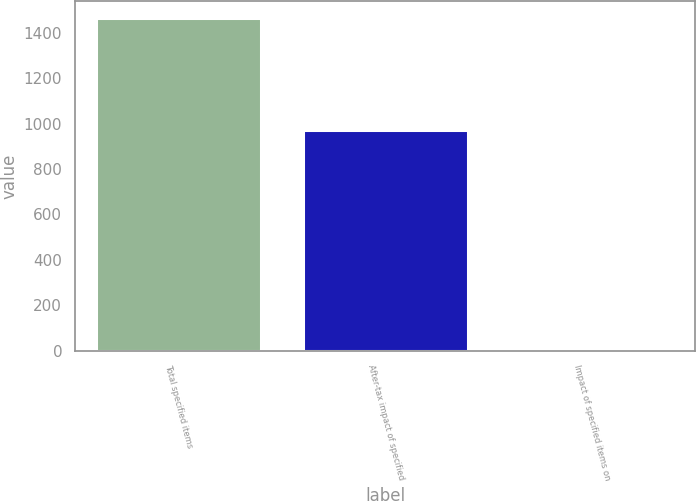<chart> <loc_0><loc_0><loc_500><loc_500><bar_chart><fcel>Total specified items<fcel>After-tax impact of specified<fcel>Impact of specified items on<nl><fcel>1466<fcel>971<fcel>4.34<nl></chart> 